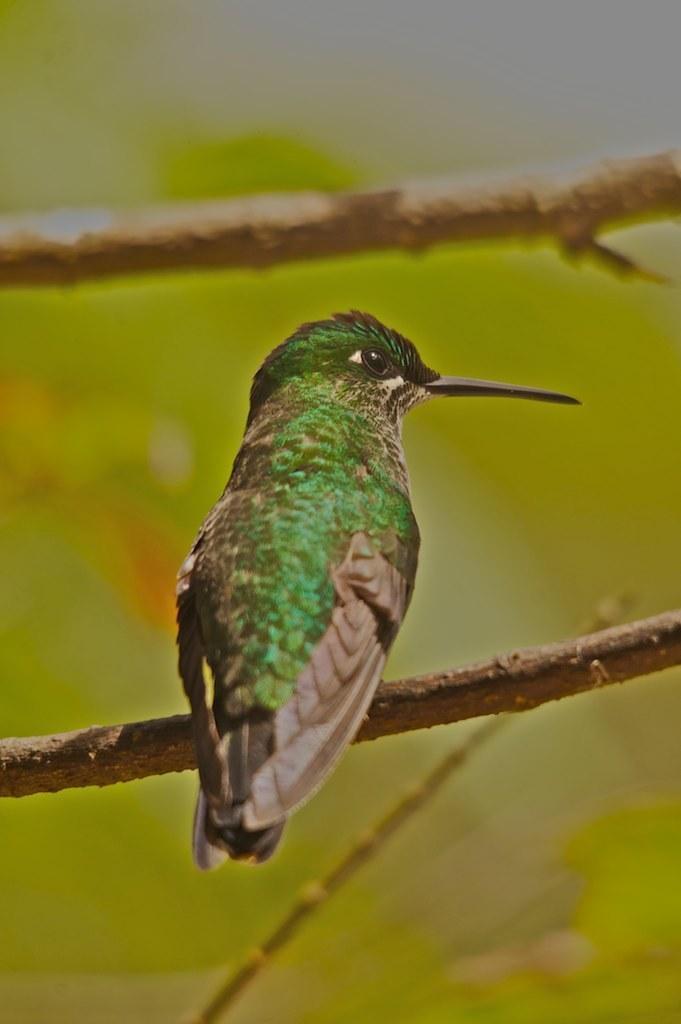Please provide a concise description of this image. In this image we can see a bird on the branch of the tree, and the background is blurred. 